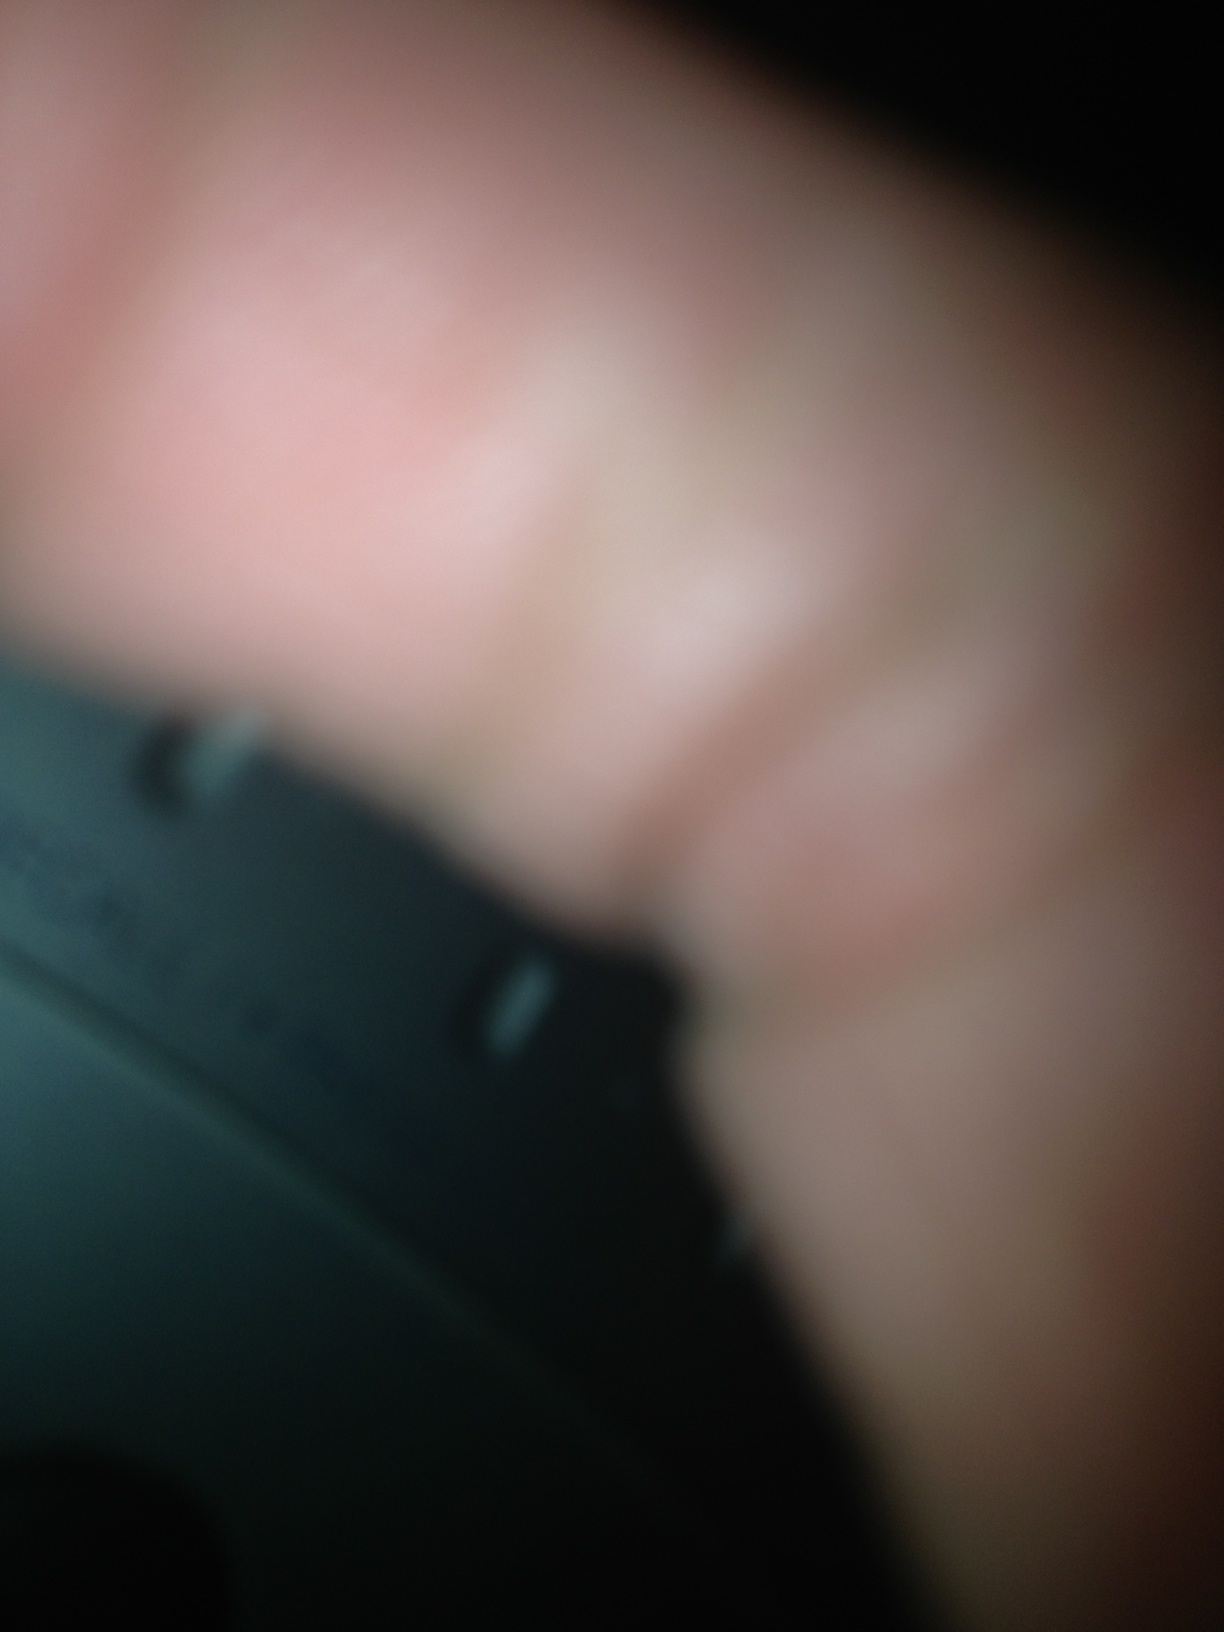Imagine you are part of a detective team. How would you use this image in your investigation? As part of the detective team, I would start by enhancing this image to glean more details. I would use image processing software to try and clarify the image, hoping to reveal more identifiable features of the object and any potential fingerprints. Concurrently, I would gather additional photographs or angles of the object to analyze the markings and any serial numbers that could trace it back to a manufacturer or owner. Coupled with witness testimonies and other evidence collected from the scene, this image could be pivotal in piecing together the events leading up to the incident. Each detail, no matter how obscure, could be the key to unraveling the mystery.  What could this mean if it were part of a crime scene? If this image were part of a crime scene, it could potentially be evidence of tampering or a critical piece of equipment used in the crime. The object in question might have been handled by the perpetrator, leading forensic teams to prioritize fingerprint analysis. It could be part of an electronic device used to bypass security systems, record conversations, or even manipulate other electronic equipment. Each hypothesis would guide the investigation towards understanding the crime's full scope. 